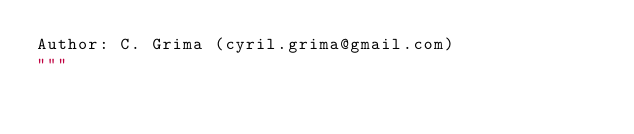Convert code to text. <code><loc_0><loc_0><loc_500><loc_500><_Python_>Author: C. Grima (cyril.grima@gmail.com)
"""
</code> 